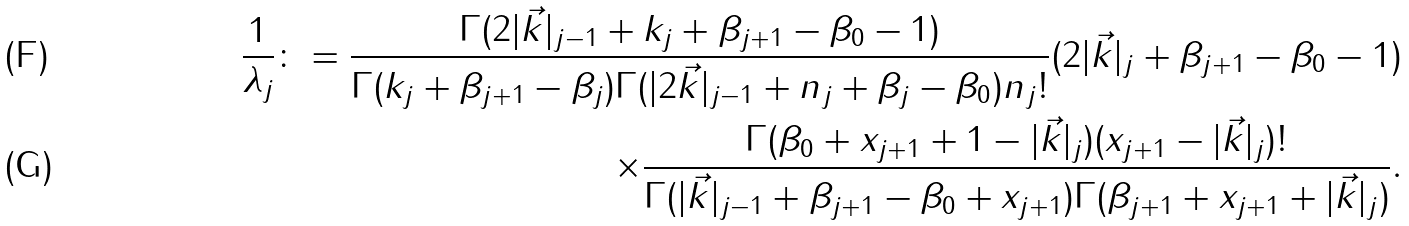<formula> <loc_0><loc_0><loc_500><loc_500>\frac { 1 } { \lambda _ { j } } \colon = \frac { \Gamma ( 2 | \vec { k } | _ { j - 1 } + k _ { j } + \beta _ { j + 1 } - \beta _ { 0 } - 1 ) } { \Gamma ( k _ { j } + \beta _ { j + 1 } - \beta _ { j } ) \Gamma ( | 2 \vec { k } | _ { j - 1 } + n _ { j } + \beta _ { j } - \beta _ { 0 } ) n _ { j } ! } ( 2 | \vec { k } | _ { j } + \beta _ { j + 1 } - \beta _ { 0 } - 1 ) \\ \times \frac { \Gamma ( \beta _ { 0 } + x _ { j + 1 } + 1 - | \vec { k } | _ { j } ) ( x _ { j + 1 } - | \vec { k } | _ { j } ) ! } { \Gamma ( | \vec { k } | _ { j - 1 } + \beta _ { j + 1 } - \beta _ { 0 } + x _ { j + 1 } ) \Gamma ( \beta _ { j + 1 } + x _ { j + 1 } + | \vec { k } | _ { j } ) } .</formula> 